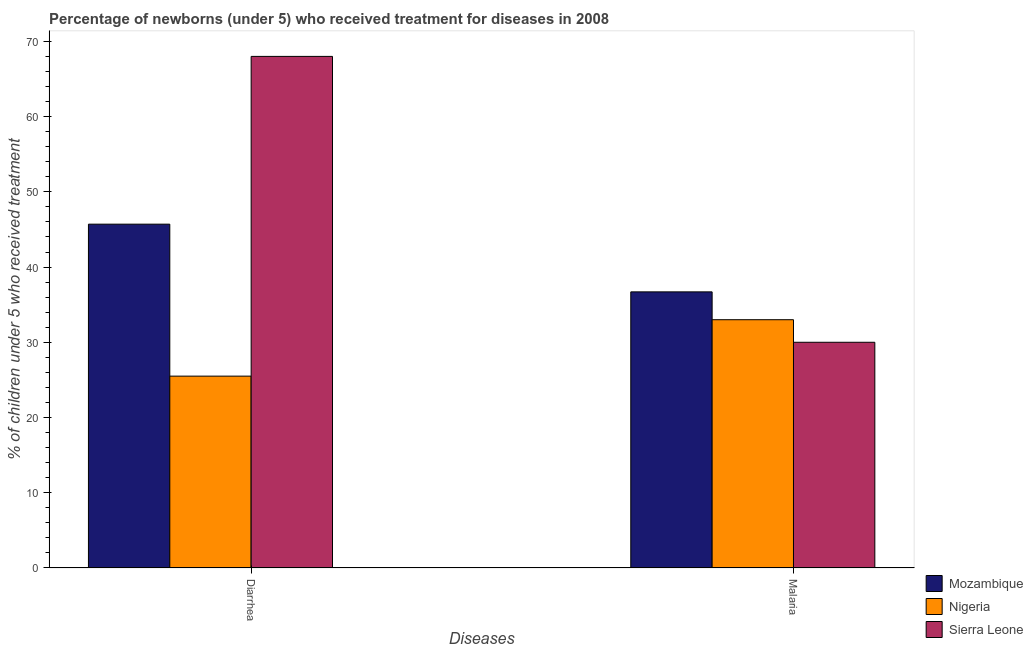How many different coloured bars are there?
Offer a very short reply. 3. How many groups of bars are there?
Your answer should be compact. 2. Are the number of bars on each tick of the X-axis equal?
Your answer should be very brief. Yes. What is the label of the 2nd group of bars from the left?
Offer a very short reply. Malaria. What is the percentage of children who received treatment for malaria in Mozambique?
Give a very brief answer. 36.7. Across all countries, what is the maximum percentage of children who received treatment for malaria?
Your response must be concise. 36.7. Across all countries, what is the minimum percentage of children who received treatment for malaria?
Offer a terse response. 30. In which country was the percentage of children who received treatment for malaria maximum?
Provide a short and direct response. Mozambique. In which country was the percentage of children who received treatment for diarrhoea minimum?
Provide a succinct answer. Nigeria. What is the total percentage of children who received treatment for malaria in the graph?
Ensure brevity in your answer.  99.7. What is the difference between the percentage of children who received treatment for diarrhoea in Mozambique and the percentage of children who received treatment for malaria in Sierra Leone?
Offer a very short reply. 15.7. What is the average percentage of children who received treatment for diarrhoea per country?
Ensure brevity in your answer.  46.4. What is the difference between the percentage of children who received treatment for malaria and percentage of children who received treatment for diarrhoea in Mozambique?
Offer a terse response. -9. In how many countries, is the percentage of children who received treatment for malaria greater than 32 %?
Your answer should be very brief. 2. What is the ratio of the percentage of children who received treatment for diarrhoea in Sierra Leone to that in Nigeria?
Provide a short and direct response. 2.67. Is the percentage of children who received treatment for malaria in Mozambique less than that in Sierra Leone?
Make the answer very short. No. What does the 2nd bar from the left in Diarrhea represents?
Provide a succinct answer. Nigeria. What does the 3rd bar from the right in Diarrhea represents?
Your answer should be very brief. Mozambique. How many bars are there?
Your answer should be very brief. 6. Are all the bars in the graph horizontal?
Your answer should be compact. No. How many countries are there in the graph?
Offer a very short reply. 3. Does the graph contain grids?
Make the answer very short. No. Where does the legend appear in the graph?
Provide a succinct answer. Bottom right. How many legend labels are there?
Ensure brevity in your answer.  3. What is the title of the graph?
Your response must be concise. Percentage of newborns (under 5) who received treatment for diseases in 2008. Does "Dominican Republic" appear as one of the legend labels in the graph?
Offer a very short reply. No. What is the label or title of the X-axis?
Your response must be concise. Diseases. What is the label or title of the Y-axis?
Keep it short and to the point. % of children under 5 who received treatment. What is the % of children under 5 who received treatment of Mozambique in Diarrhea?
Provide a short and direct response. 45.7. What is the % of children under 5 who received treatment in Nigeria in Diarrhea?
Give a very brief answer. 25.5. What is the % of children under 5 who received treatment in Mozambique in Malaria?
Provide a succinct answer. 36.7. What is the % of children under 5 who received treatment of Nigeria in Malaria?
Your response must be concise. 33. What is the % of children under 5 who received treatment of Sierra Leone in Malaria?
Provide a succinct answer. 30. Across all Diseases, what is the maximum % of children under 5 who received treatment in Mozambique?
Make the answer very short. 45.7. Across all Diseases, what is the maximum % of children under 5 who received treatment of Sierra Leone?
Ensure brevity in your answer.  68. Across all Diseases, what is the minimum % of children under 5 who received treatment in Mozambique?
Keep it short and to the point. 36.7. What is the total % of children under 5 who received treatment in Mozambique in the graph?
Keep it short and to the point. 82.4. What is the total % of children under 5 who received treatment of Nigeria in the graph?
Give a very brief answer. 58.5. What is the total % of children under 5 who received treatment of Sierra Leone in the graph?
Your answer should be compact. 98. What is the difference between the % of children under 5 who received treatment in Nigeria in Diarrhea and that in Malaria?
Provide a succinct answer. -7.5. What is the difference between the % of children under 5 who received treatment in Sierra Leone in Diarrhea and that in Malaria?
Make the answer very short. 38. What is the average % of children under 5 who received treatment in Mozambique per Diseases?
Ensure brevity in your answer.  41.2. What is the average % of children under 5 who received treatment of Nigeria per Diseases?
Give a very brief answer. 29.25. What is the average % of children under 5 who received treatment of Sierra Leone per Diseases?
Provide a short and direct response. 49. What is the difference between the % of children under 5 who received treatment in Mozambique and % of children under 5 who received treatment in Nigeria in Diarrhea?
Offer a very short reply. 20.2. What is the difference between the % of children under 5 who received treatment of Mozambique and % of children under 5 who received treatment of Sierra Leone in Diarrhea?
Your answer should be compact. -22.3. What is the difference between the % of children under 5 who received treatment in Nigeria and % of children under 5 who received treatment in Sierra Leone in Diarrhea?
Your response must be concise. -42.5. What is the ratio of the % of children under 5 who received treatment in Mozambique in Diarrhea to that in Malaria?
Your response must be concise. 1.25. What is the ratio of the % of children under 5 who received treatment in Nigeria in Diarrhea to that in Malaria?
Ensure brevity in your answer.  0.77. What is the ratio of the % of children under 5 who received treatment in Sierra Leone in Diarrhea to that in Malaria?
Provide a short and direct response. 2.27. What is the difference between the highest and the second highest % of children under 5 who received treatment in Mozambique?
Your answer should be compact. 9. What is the difference between the highest and the lowest % of children under 5 who received treatment of Mozambique?
Ensure brevity in your answer.  9. What is the difference between the highest and the lowest % of children under 5 who received treatment of Sierra Leone?
Offer a terse response. 38. 